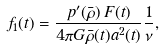Convert formula to latex. <formula><loc_0><loc_0><loc_500><loc_500>f _ { 1 } ( t ) = \frac { p ^ { \prime } ( \bar { \rho } ) \, F ( t ) } { 4 \pi G \bar { \rho } ( t ) a ^ { 2 } ( t ) } \frac { 1 } { \nu } ,</formula> 